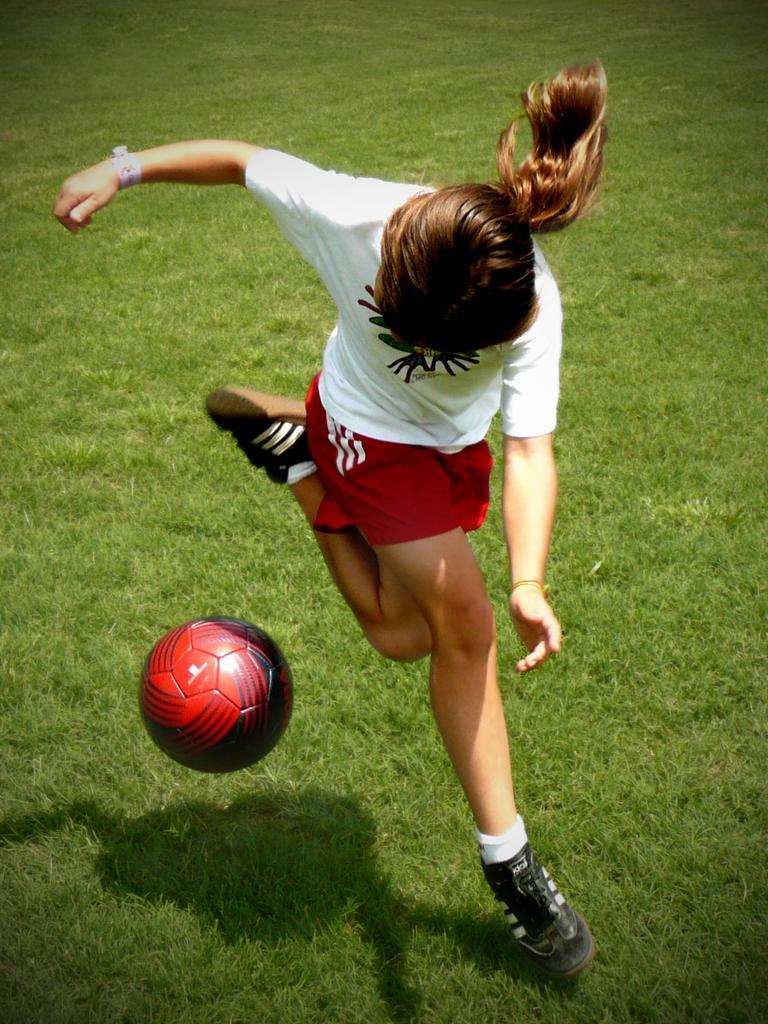In one or two sentences, can you explain what this image depicts? This image consists of a girl playing football. At the bottom, there is green grass. To the left, there is a ball. She is wearing a white and red color sports dress. 